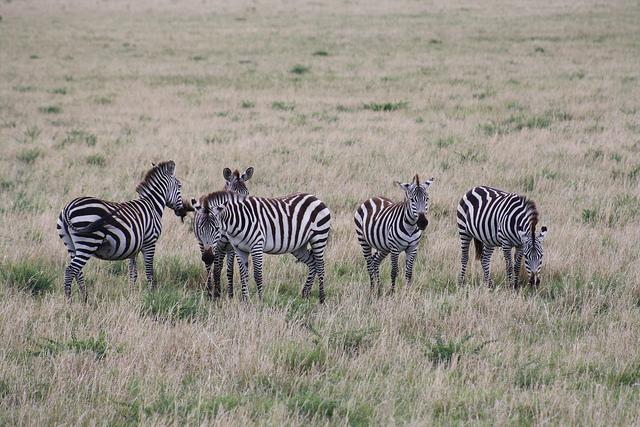How many zebra?
Concise answer only. 5. Are they in the jungle?
Be succinct. No. What animals are in the photo?
Short answer required. Zebras. Are they in their natural habitat?
Be succinct. Yes. Are the zebras looking for something?
Quick response, please. No. Do you see lots of trees?
Give a very brief answer. No. How many zebras are there?
Keep it brief. 5. 